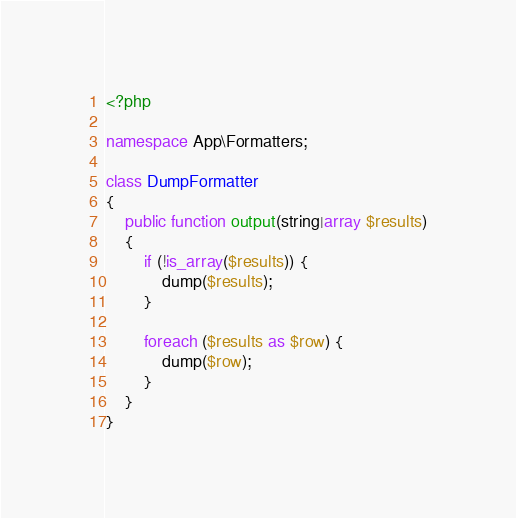Convert code to text. <code><loc_0><loc_0><loc_500><loc_500><_PHP_><?php

namespace App\Formatters;

class DumpFormatter
{
    public function output(string|array $results)
    {
        if (!is_array($results)) {
            dump($results);
        }

        foreach ($results as $row) {
            dump($row);
        }
    }
}
</code> 